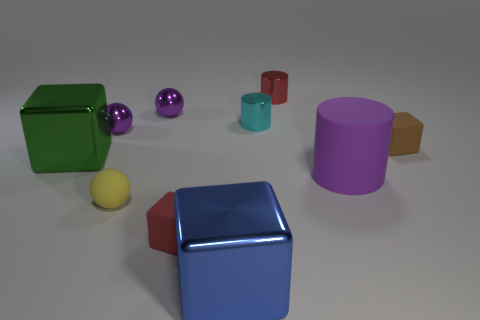How many objects are either small rubber things that are on the right side of the red rubber thing or big blue things?
Provide a succinct answer. 2. There is a red cube that is the same material as the large purple cylinder; what is its size?
Offer a terse response. Small. What number of tiny objects have the same color as the big rubber object?
Provide a succinct answer. 2. What number of small things are either yellow objects or cyan rubber things?
Your answer should be compact. 1. Are there any brown blocks made of the same material as the large cylinder?
Provide a succinct answer. Yes. What is the tiny red cylinder to the right of the yellow ball made of?
Keep it short and to the point. Metal. There is a rubber thing that is on the right side of the big purple object; is it the same color as the large object that is to the left of the large blue object?
Your response must be concise. No. There is a matte cube that is the same size as the brown thing; what color is it?
Your answer should be compact. Red. How many other objects are the same shape as the small red rubber object?
Your answer should be very brief. 3. How big is the metallic cube that is on the left side of the yellow object?
Your response must be concise. Large. 